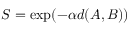Convert formula to latex. <formula><loc_0><loc_0><loc_500><loc_500>S = \exp ( - \alpha { d ( A , B ) } )</formula> 